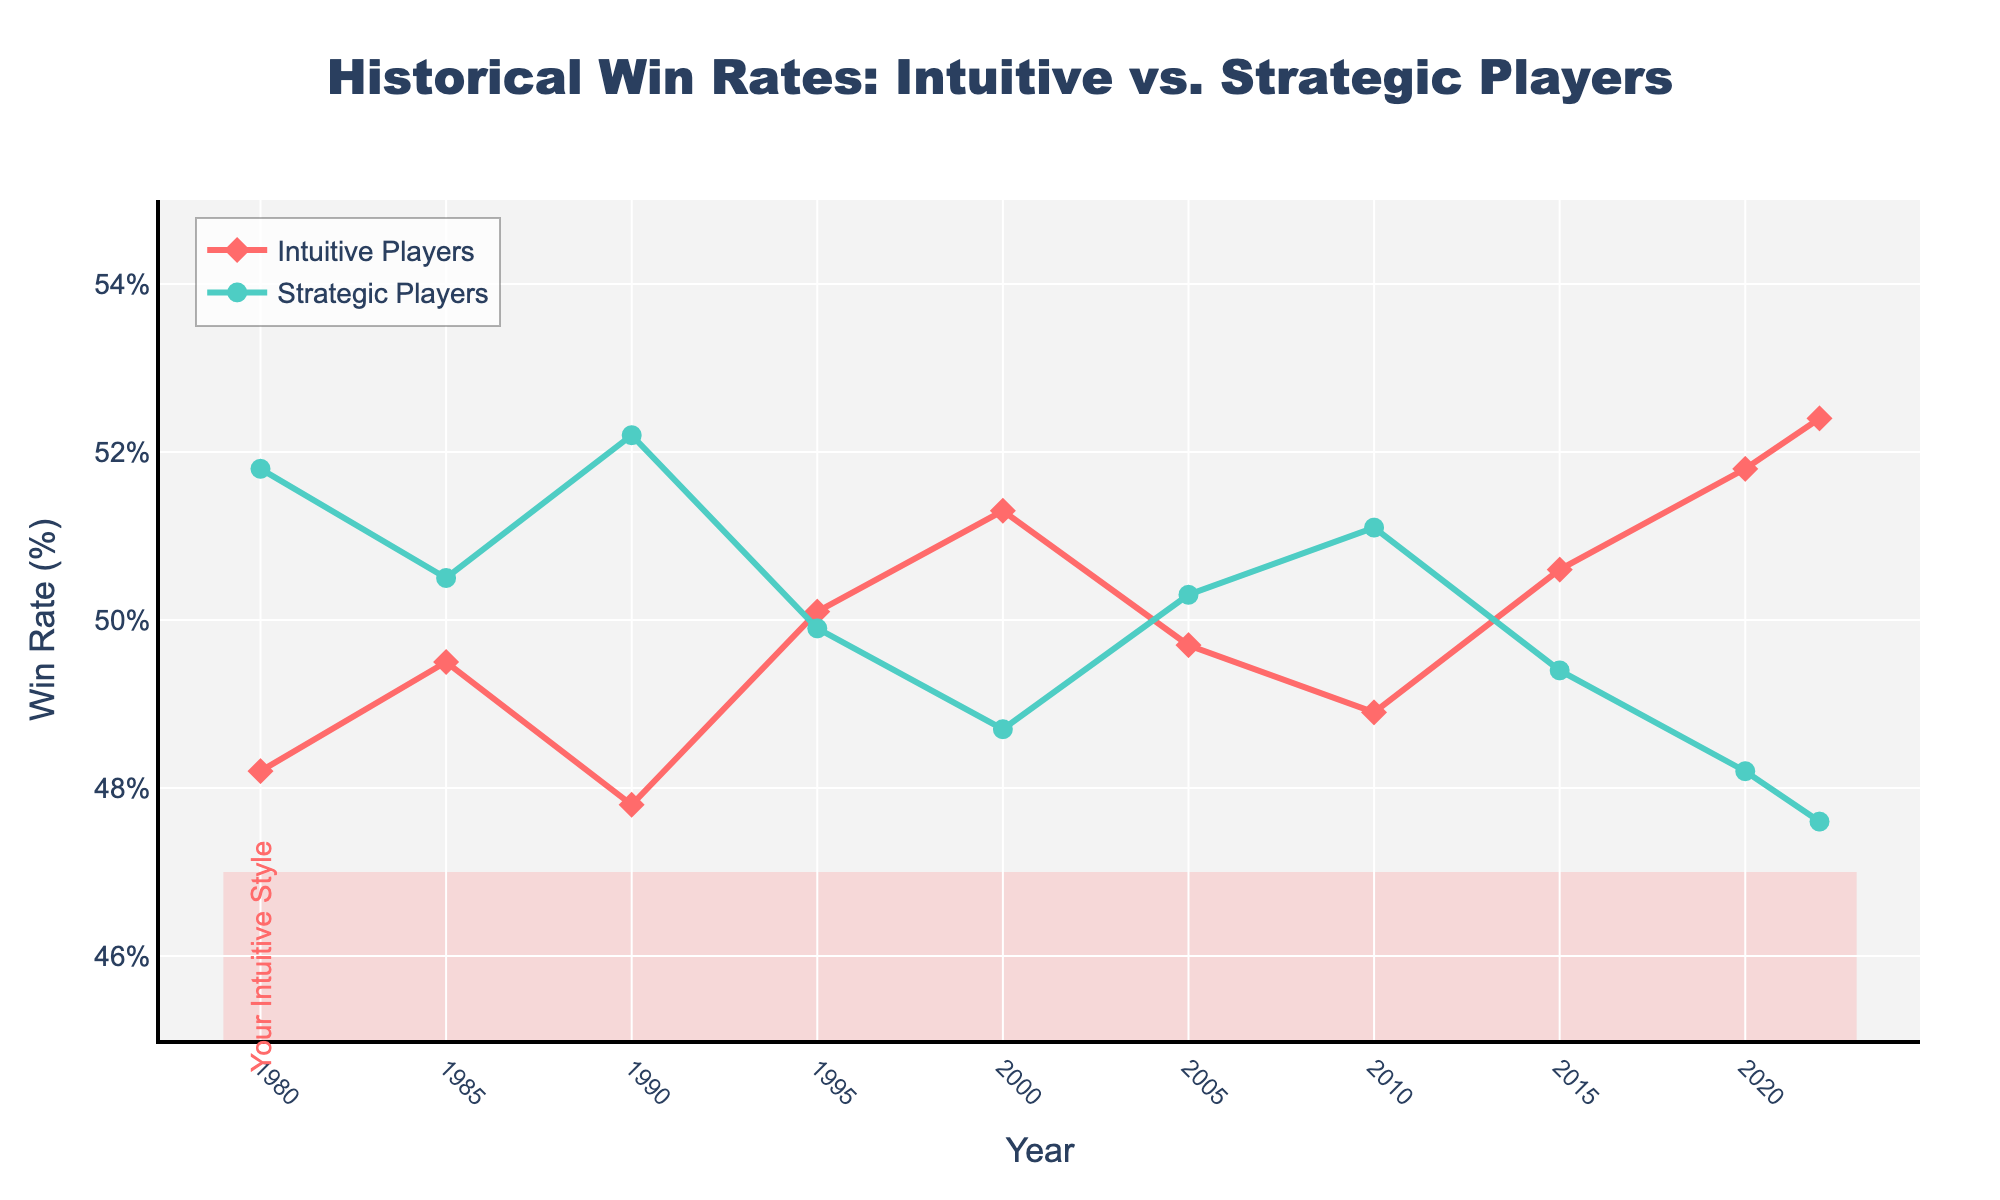What was the win rate of intuitive players in 1995? The plot shows a line marker for intuitive players in 1995 at approximately 50.1%.
Answer: 50.1% How did the win rates of intuitive players compare to strategic players in 2022? In 2022, the line for intuitive players is above that of strategic players. Intuitive players had a win rate of about 52.4%, while strategic players had about 47.6%.
Answer: Intuitive players: 52.4%, Strategic players: 47.6% During which year did intuitive players have their lowest win rate, and what was it? The lowest point in the intuitive players' line is in 1990, with a win rate of approximately 47.8%.
Answer: 1990, 47.8% Was there any year when the win rates of intuitive players were greater than or equal to the win rates of strategic players? The intuitive players' line intersects or is above the strategic players' line around the years 1995, 2000, 2015, 2020, and 2022.
Answer: Yes, multiple years (1995, 2000, 2015, 2020, 2022) Calculate the average win rate of intuitive players across the given years. Summing the win rates of intuitive players across the years and dividing by the number of years (10), we have (48.2 + 49.5 + 47.8 + 50.1 + 51.3 + 49.7 + 48.9 + 50.6 + 51.8 + 52.4) / 10 = 50.03%.
Answer: 50.03% Which year saw the highest win rate for strategic players, and what was it? The highest win rate for strategic players occurred in 1990, with about 52.2%.
Answer: 1990, 52.2% What is the overall trend for the win rates of intuitive players from 1980 to 2022? The trend for intuitive players' win rates generally shows an increase, starting around 48.2% in 1980 and ending at 52.4% in 2022.
Answer: Increasing Compare the difference in win rates between intuitive and strategic players in 1980 and 2022. In 1980, intuitive players had a win rate of 48.2% and strategic players 51.8% (difference of -3.6%). In 2022, intuitive players had 52.4% and strategic players 47.6% (difference of 4.8%).
Answer: 1980: -3.6%, 2022: 4.8% Identify any periods where strategic players consistently had higher win rates than intuitive players. The strategic players' win rates are consistently higher than intuitive players' from 1980 to 1990 and from 2005 to 2010.
Answer: 1980-1990, 2005-2010 